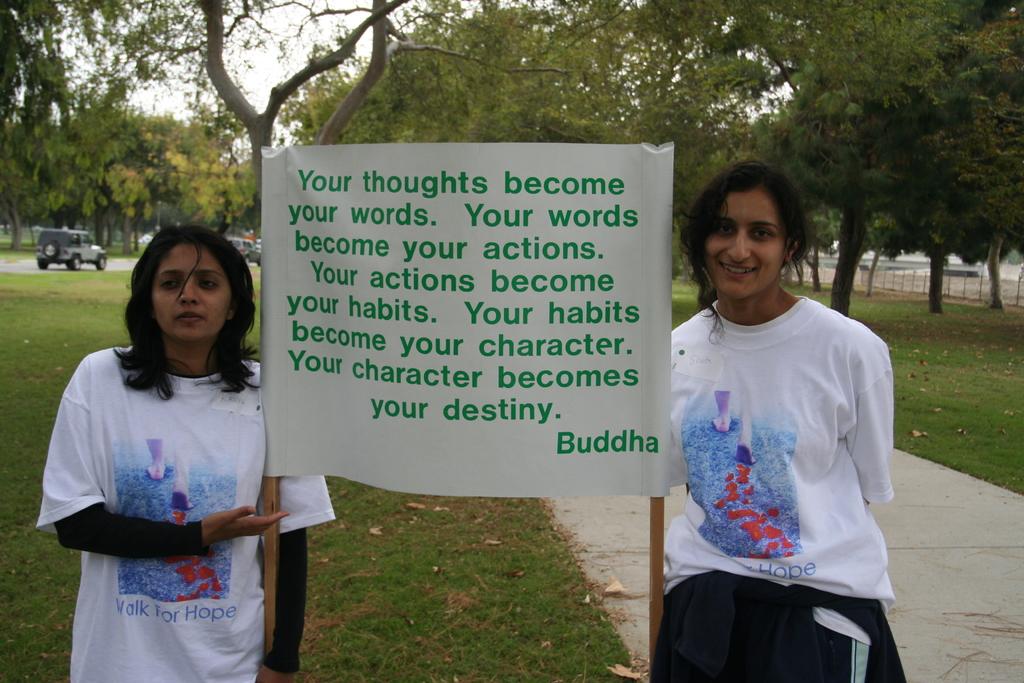What do one's words become?
Provide a succinct answer. Your actions. Who is this a quote from?
Offer a terse response. Buddha. 